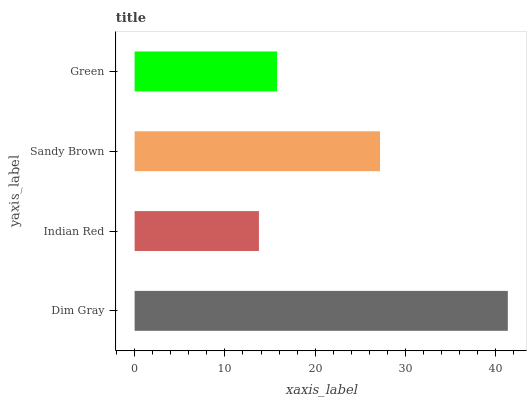Is Indian Red the minimum?
Answer yes or no. Yes. Is Dim Gray the maximum?
Answer yes or no. Yes. Is Sandy Brown the minimum?
Answer yes or no. No. Is Sandy Brown the maximum?
Answer yes or no. No. Is Sandy Brown greater than Indian Red?
Answer yes or no. Yes. Is Indian Red less than Sandy Brown?
Answer yes or no. Yes. Is Indian Red greater than Sandy Brown?
Answer yes or no. No. Is Sandy Brown less than Indian Red?
Answer yes or no. No. Is Sandy Brown the high median?
Answer yes or no. Yes. Is Green the low median?
Answer yes or no. Yes. Is Indian Red the high median?
Answer yes or no. No. Is Dim Gray the low median?
Answer yes or no. No. 